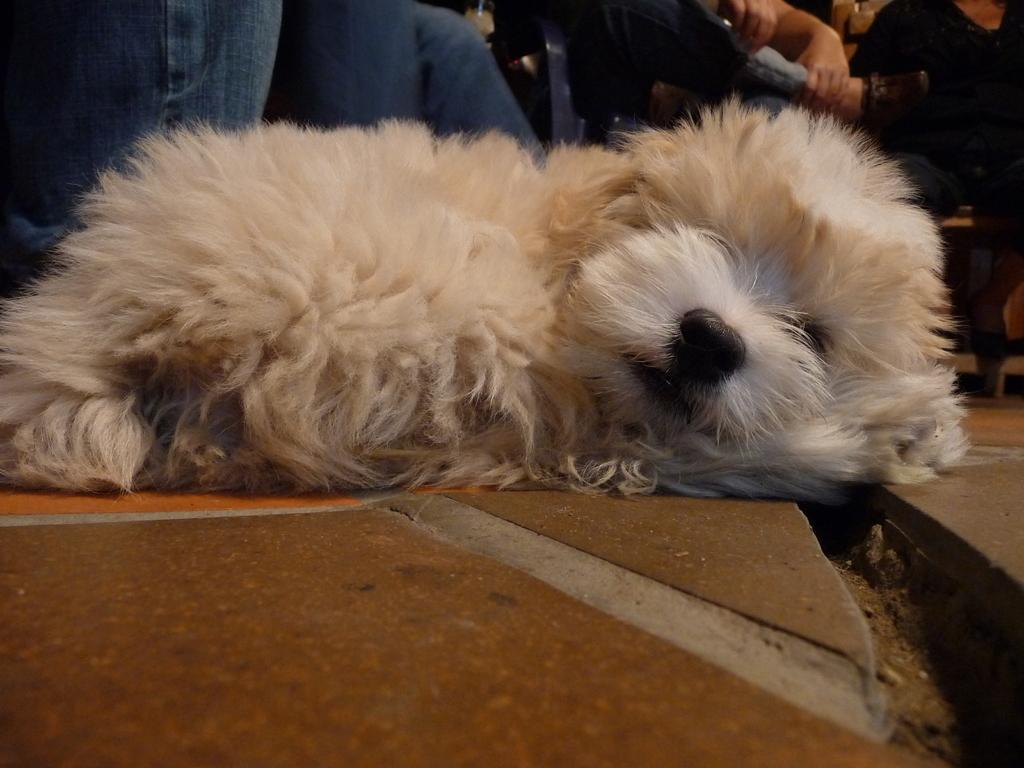In one or two sentences, can you explain what this image depicts? In this image I can see the dog on the brown color surface. The dog is in white and cream color. In the background I can see the group of people with blue and black color dresses. 